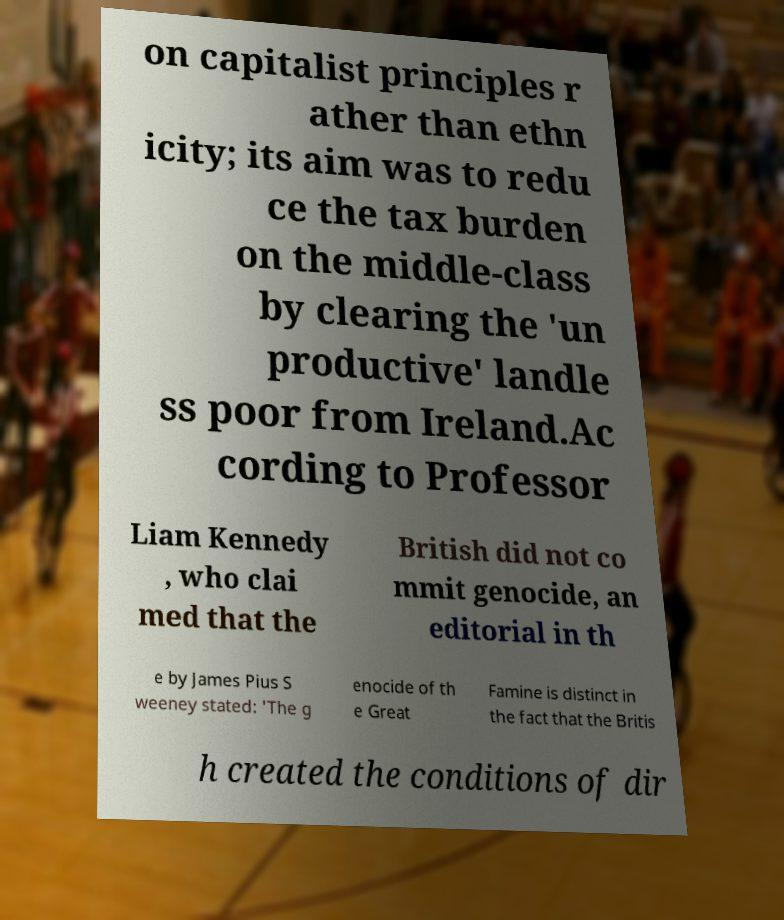For documentation purposes, I need the text within this image transcribed. Could you provide that? on capitalist principles r ather than ethn icity; its aim was to redu ce the tax burden on the middle-class by clearing the 'un productive' landle ss poor from Ireland.Ac cording to Professor Liam Kennedy , who clai med that the British did not co mmit genocide, an editorial in th e by James Pius S weeney stated: 'The g enocide of th e Great Famine is distinct in the fact that the Britis h created the conditions of dir 